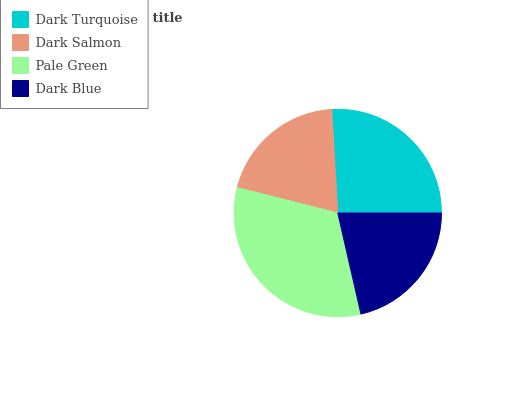Is Dark Salmon the minimum?
Answer yes or no. Yes. Is Pale Green the maximum?
Answer yes or no. Yes. Is Pale Green the minimum?
Answer yes or no. No. Is Dark Salmon the maximum?
Answer yes or no. No. Is Pale Green greater than Dark Salmon?
Answer yes or no. Yes. Is Dark Salmon less than Pale Green?
Answer yes or no. Yes. Is Dark Salmon greater than Pale Green?
Answer yes or no. No. Is Pale Green less than Dark Salmon?
Answer yes or no. No. Is Dark Turquoise the high median?
Answer yes or no. Yes. Is Dark Blue the low median?
Answer yes or no. Yes. Is Pale Green the high median?
Answer yes or no. No. Is Dark Turquoise the low median?
Answer yes or no. No. 